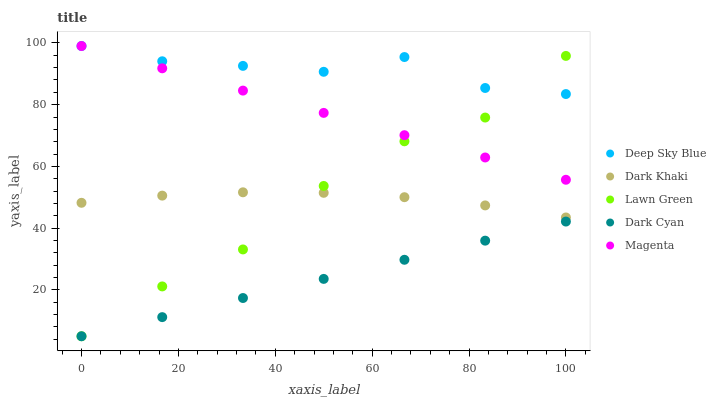Does Dark Cyan have the minimum area under the curve?
Answer yes or no. Yes. Does Deep Sky Blue have the maximum area under the curve?
Answer yes or no. Yes. Does Lawn Green have the minimum area under the curve?
Answer yes or no. No. Does Lawn Green have the maximum area under the curve?
Answer yes or no. No. Is Dark Cyan the smoothest?
Answer yes or no. Yes. Is Lawn Green the roughest?
Answer yes or no. Yes. Is Magenta the smoothest?
Answer yes or no. No. Is Magenta the roughest?
Answer yes or no. No. Does Lawn Green have the lowest value?
Answer yes or no. Yes. Does Magenta have the lowest value?
Answer yes or no. No. Does Deep Sky Blue have the highest value?
Answer yes or no. Yes. Does Lawn Green have the highest value?
Answer yes or no. No. Is Dark Cyan less than Dark Khaki?
Answer yes or no. Yes. Is Magenta greater than Dark Cyan?
Answer yes or no. Yes. Does Magenta intersect Lawn Green?
Answer yes or no. Yes. Is Magenta less than Lawn Green?
Answer yes or no. No. Is Magenta greater than Lawn Green?
Answer yes or no. No. Does Dark Cyan intersect Dark Khaki?
Answer yes or no. No. 